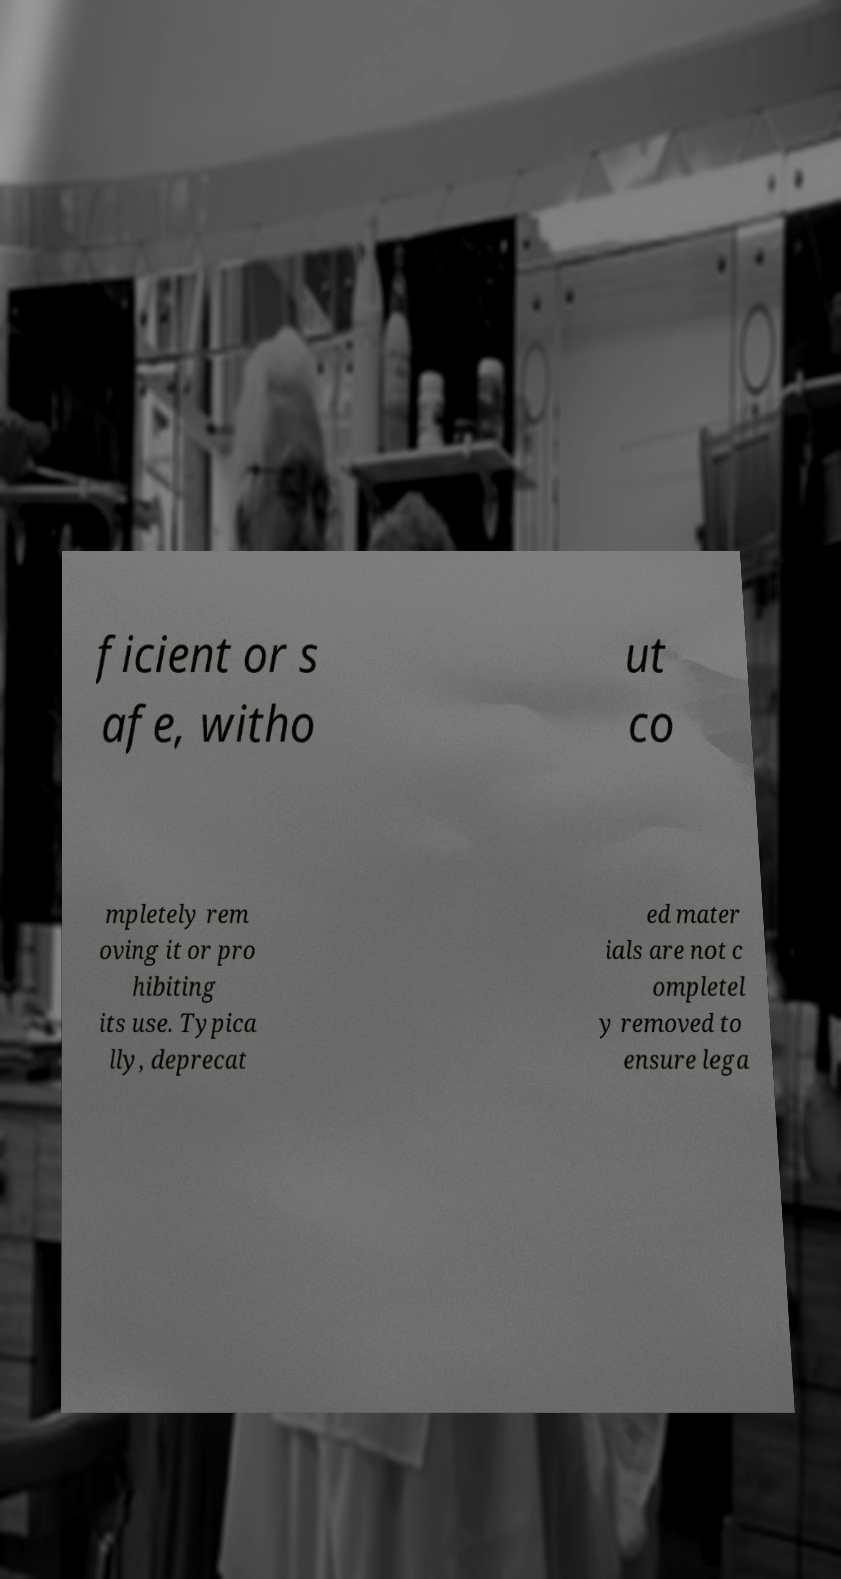Please identify and transcribe the text found in this image. ficient or s afe, witho ut co mpletely rem oving it or pro hibiting its use. Typica lly, deprecat ed mater ials are not c ompletel y removed to ensure lega 